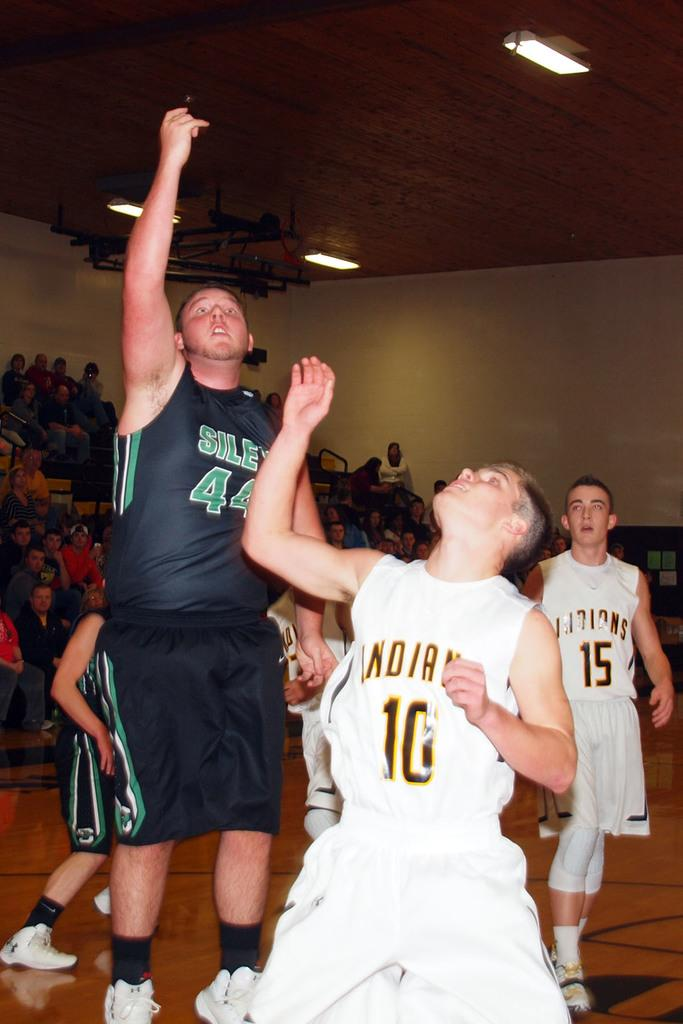<image>
Offer a succinct explanation of the picture presented. Man wearing a black number 44 jersey shooting a shot. 